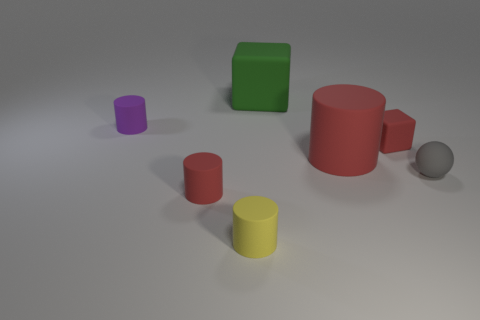What material is the big cylinder that is the same color as the small block?
Offer a very short reply. Rubber. Is the color of the large cube the same as the large cylinder?
Ensure brevity in your answer.  No. What number of things are either tiny cylinders that are behind the yellow rubber thing or big gray spheres?
Make the answer very short. 2. There is a red thing that is to the left of the rubber block that is to the left of the tiny red rubber cube; how many tiny gray spheres are on the right side of it?
Ensure brevity in your answer.  1. Are there any other things that have the same size as the gray sphere?
Provide a short and direct response. Yes. What shape is the matte object that is in front of the small red thing that is on the left side of the matte cube to the right of the green rubber block?
Offer a terse response. Cylinder. How many other things are the same color as the large matte block?
Offer a terse response. 0. What is the shape of the small red object that is to the left of the rubber cube in front of the purple thing?
Offer a very short reply. Cylinder. How many small matte cylinders are in front of the gray matte sphere?
Keep it short and to the point. 2. Are there any yellow things made of the same material as the big cylinder?
Your answer should be very brief. Yes. 